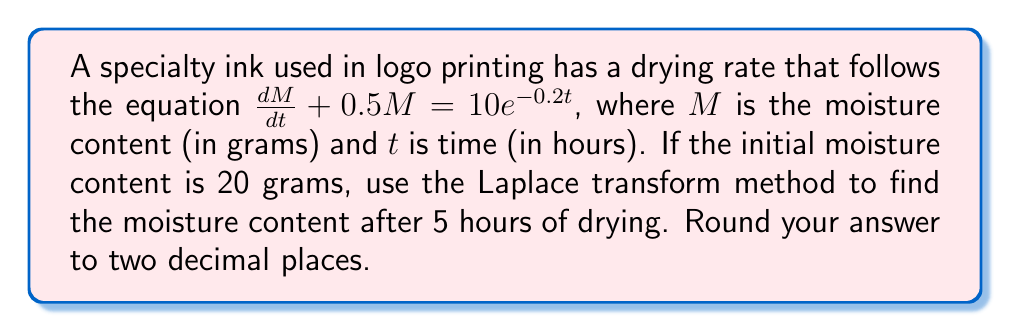What is the answer to this math problem? Let's solve this problem using the Laplace transform method:

1) First, we take the Laplace transform of both sides of the equation:
   $$\mathcal{L}\left\{\frac{dM}{dt} + 0.5M\right\} = \mathcal{L}\{10e^{-0.2t}\}$$

2) Using Laplace transform properties:
   $$sM(s) - M(0) + 0.5M(s) = \frac{10}{s+0.2}$$

3) Substitute the initial condition $M(0) = 20$:
   $$sM(s) - 20 + 0.5M(s) = \frac{10}{s+0.2}$$

4) Rearrange the equation:
   $$(s + 0.5)M(s) = 20 + \frac{10}{s+0.2}$$

5) Solve for $M(s)$:
   $$M(s) = \frac{20}{s + 0.5} + \frac{10}{(s + 0.5)(s + 0.2)}$$

6) Perform partial fraction decomposition:
   $$M(s) = \frac{20}{s + 0.5} + \frac{A}{s + 0.5} + \frac{B}{s + 0.2}$$
   where $A = \frac{10}{0.3} = \frac{100}{3}$ and $B = -\frac{10}{0.3} = -\frac{100}{3}$

7) Now we have:
   $$M(s) = \frac{20}{s + 0.5} + \frac{100/3}{s + 0.5} - \frac{100/3}{s + 0.2}$$

8) Take the inverse Laplace transform:
   $$M(t) = \left(20 + \frac{100}{3}\right)e^{-0.5t} - \frac{100}{3}e^{-0.2t}$$

9) Simplify:
   $$M(t) = \frac{160}{3}e^{-0.5t} - \frac{100}{3}e^{-0.2t}$$

10) To find the moisture content after 5 hours, substitute $t = 5$:
    $$M(5) = \frac{160}{3}e^{-0.5(5)} - \frac{100}{3}e^{-0.2(5)}$$

11) Calculate:
    $$M(5) = \frac{160}{3}e^{-2.5} - \frac{100}{3}e^{-1} \approx 4.82$$

Therefore, the moisture content after 5 hours of drying is approximately 4.82 grams.
Answer: 4.82 grams 